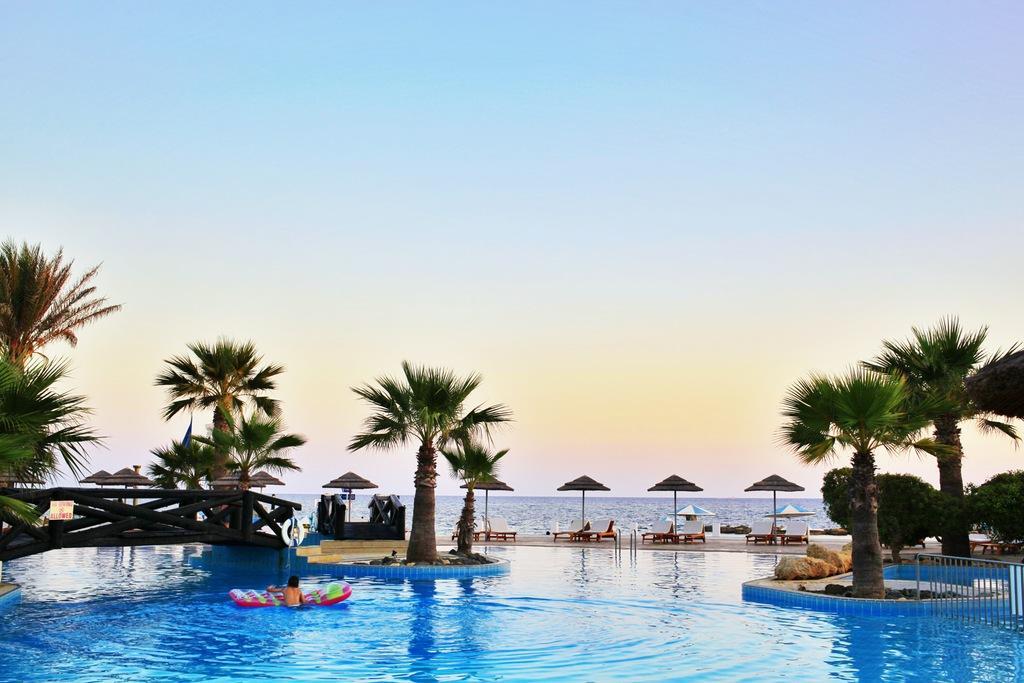Describe this image in one or two sentences. In the background we can see the sky. In this picture we can see swimming pool, umbrellas, trees, objects, hammock chairs, bridge. On the rights side of the picture we can see railing. We can see a person on an inflatable object. 